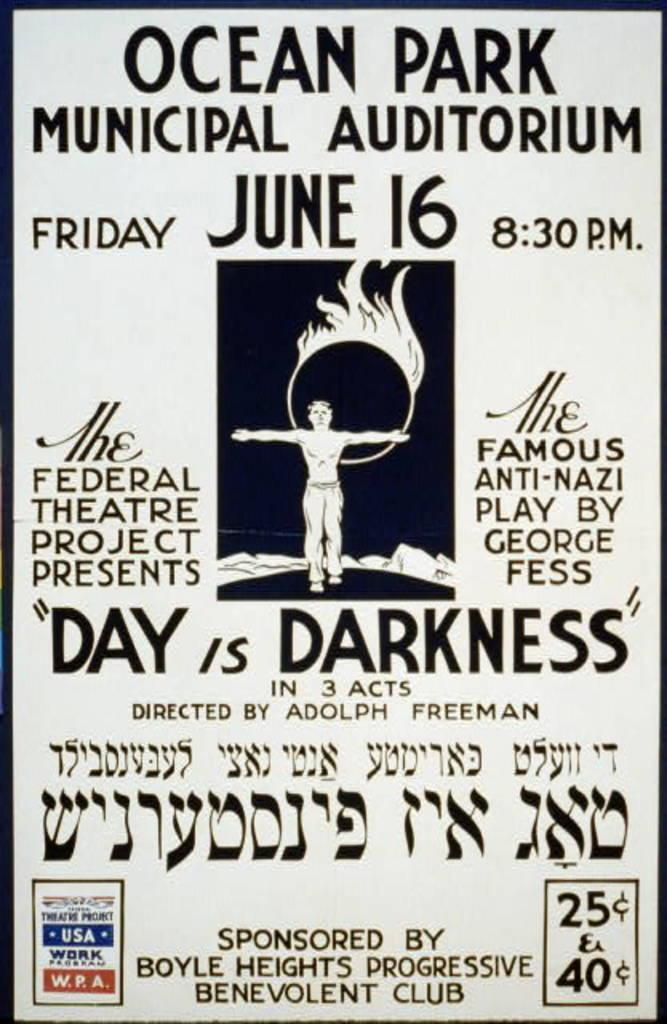<image>
Present a compact description of the photo's key features. A poster reads "Ocean Park Muncipal Auditorium" at the top. 